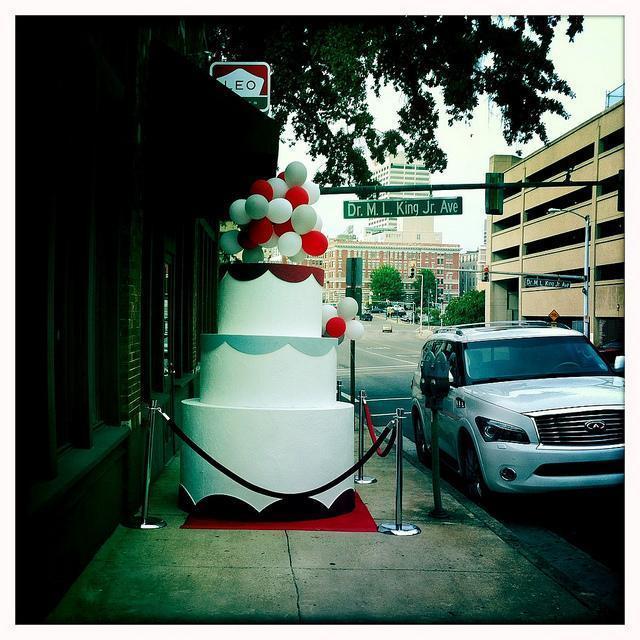How many tiers are on the cake?
Give a very brief answer. 3. 